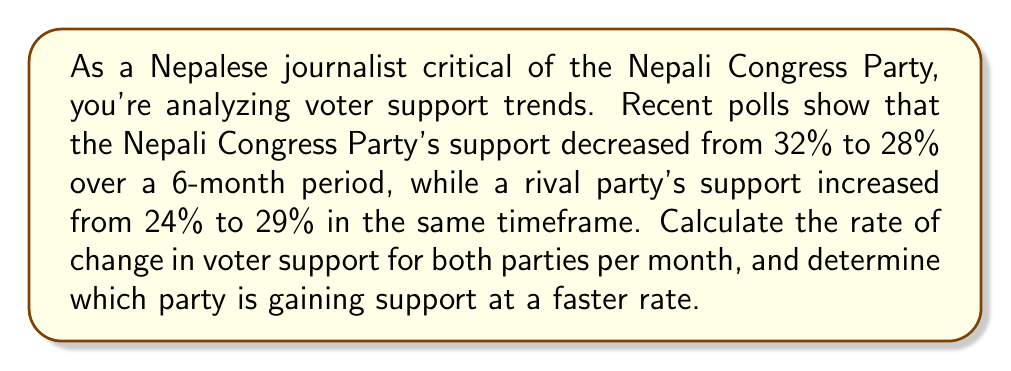Help me with this question. Let's approach this step-by-step:

1) For the Nepali Congress Party:
   Initial support: 32%
   Final support: 28%
   Time period: 6 months

   Rate of change = $\frac{\text{Change in support}}{\text{Time period}}$

   $$\text{Rate of change}_{\text{NCP}} = \frac{28\% - 32\%}{6 \text{ months}} = \frac{-4\%}{6 \text{ months}} = -\frac{2}{3}\% \text{ per month}$$

2) For the rival party:
   Initial support: 24%
   Final support: 29%
   Time period: 6 months

   $$\text{Rate of change}_{\text{Rival}} = \frac{29\% - 24\%}{6 \text{ months}} = \frac{5\%}{6 \text{ months}} = \frac{5}{6}\% \text{ per month}$$

3) To determine which party is gaining support at a faster rate, we compare the absolute values of the rates:

   $|\text{Rate of change}_{\text{NCP}}| = \frac{2}{3}\% \text{ per month}$
   $|\text{Rate of change}_{\text{Rival}}| = \frac{5}{6}\% \text{ per month}$

   Since $\frac{5}{6} > \frac{2}{3}$, the rival party is gaining support at a faster rate.
Answer: The Nepali Congress Party's support is changing at a rate of $-\frac{2}{3}\%$ per month, while the rival party's support is changing at a rate of $\frac{5}{6}\%$ per month. The rival party is gaining support at a faster rate. 